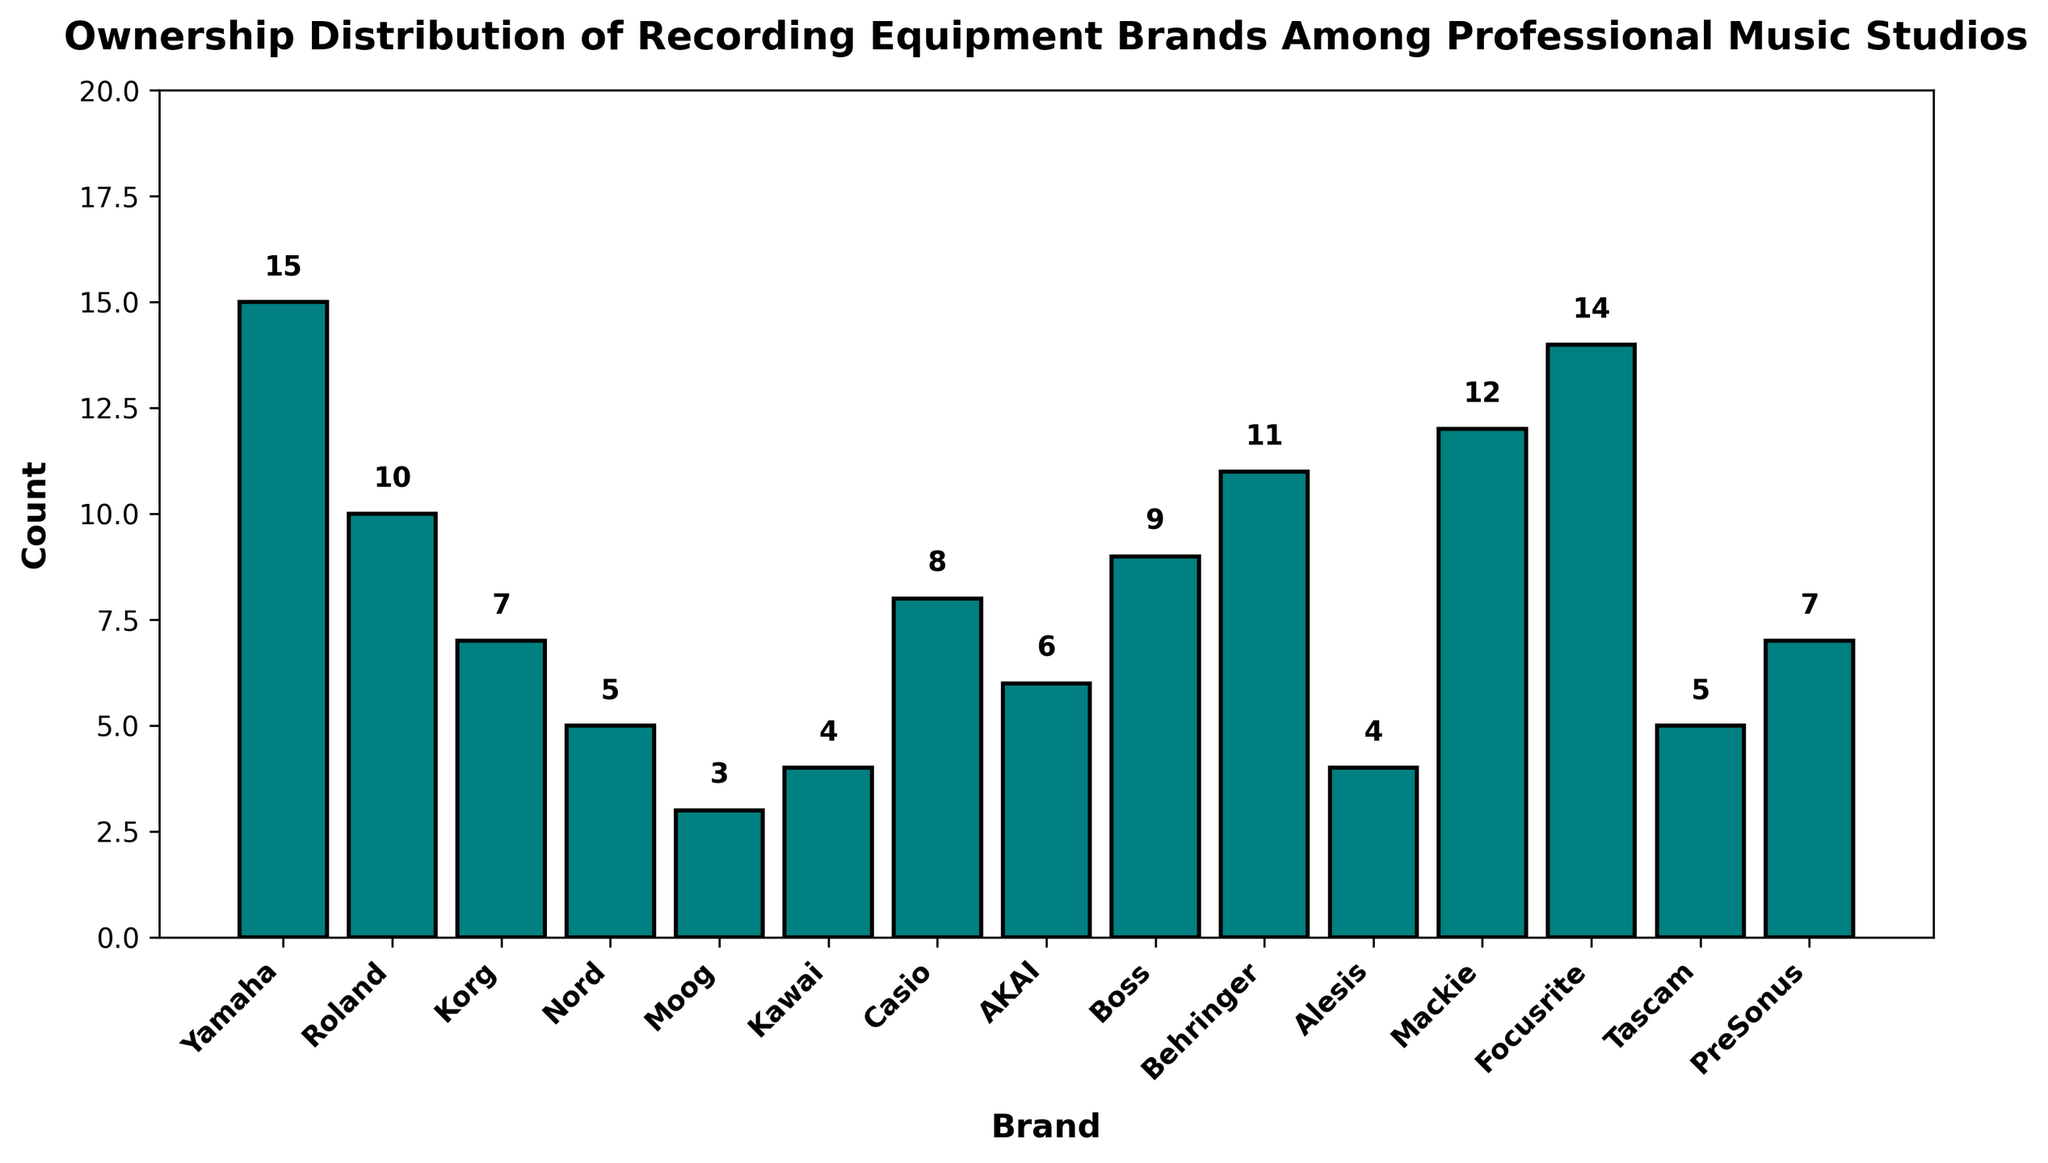Which brand has the highest count of ownership among professional music studios? Look at the bar with the highest height. In this plot, Yamaha has a count of 15, which is the highest.
Answer: Yamaha Which brand has the lowest count of ownership among professional music studios? Look at the bar with the shortest height. Moog has a count of 3, which is the lowest.
Answer: Moog How many more studios own Behringer equipment than Kawai equipment? Behringer has a count of 11 and Kawai has a count of 4. Subtract the lower count from the higher count: 11 - 4 = 7.
Answer: 7 What is the total number of studios owning either Roland or Boss equipment? Roland has a count of 10 and Boss has a count of 9. Add these counts together: 10 + 9 = 19.
Answer: 19 Which brand has a count closest to the median value of ownership among all brands? First, list all counts in order: [3, 4, 4, 5, 5, 6, 7, 7, 8, 9, 10, 11, 12, 14, 15]. The median value is the middle value (8th item in the sorted list since there are 15 data points), which is 7. Both Korg and PreSonus have a count of 7.
Answer: Korg and PreSonus Is the count of Yamaha greater than the combined count of Moog and Nord? Yamaha has a count of 15. Moog and Nord have counts of 3 and 5 respectively. Add the counts of Moog and Nord: 3 + 5 = 8. Compare 15 (Yamaha) with 8 (Moog and Nord combined): 15 > 8.
Answer: Yes How many studios own brands that have a count of more than 10? The brands with counts more than 10 are Yamaha (15), Behringer (11), Focusrite (14), and Mackie (12). Count these brands: 4 brands have more than 10.
Answer: 4 What is the average count of ownership across all brands? Sum all counts: 15 + 10 + 7 + 5 + 3 + 4 + 8 + 6 + 9 + 11 + 4 + 12 + 14 + 5 + 7 = 120. There are 15 brands. Divide the total sum by the number of brands: 120/15 = 8.
Answer: 8 